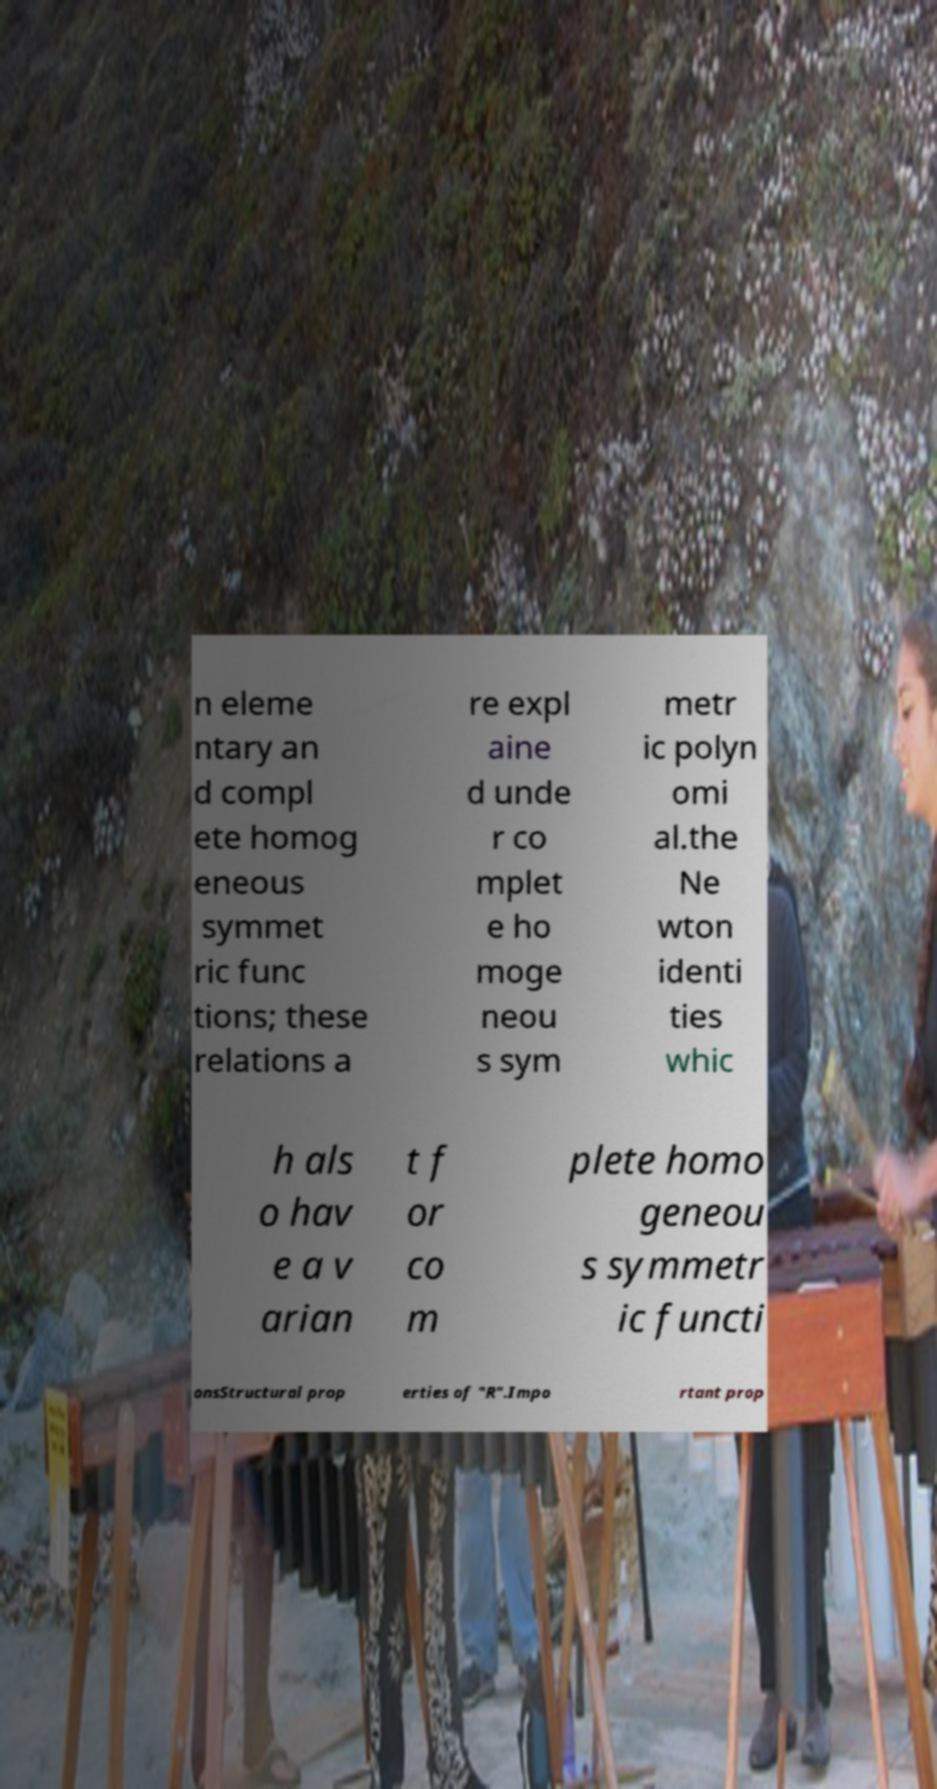Please read and relay the text visible in this image. What does it say? n eleme ntary an d compl ete homog eneous symmet ric func tions; these relations a re expl aine d unde r co mplet e ho moge neou s sym metr ic polyn omi al.the Ne wton identi ties whic h als o hav e a v arian t f or co m plete homo geneou s symmetr ic functi onsStructural prop erties of "R".Impo rtant prop 